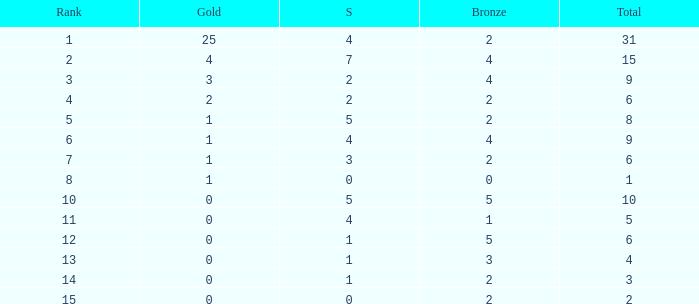Would you be able to parse every entry in this table? {'header': ['Rank', 'Gold', 'S', 'Bronze', 'Total'], 'rows': [['1', '25', '4', '2', '31'], ['2', '4', '7', '4', '15'], ['3', '3', '2', '4', '9'], ['4', '2', '2', '2', '6'], ['5', '1', '5', '2', '8'], ['6', '1', '4', '4', '9'], ['7', '1', '3', '2', '6'], ['8', '1', '0', '0', '1'], ['10', '0', '5', '5', '10'], ['11', '0', '4', '1', '5'], ['12', '0', '1', '5', '6'], ['13', '0', '1', '3', '4'], ['14', '0', '1', '2', '3'], ['15', '0', '0', '2', '2']]} What is the highest rank of the medal total less than 15, more than 2 bronzes, 0 gold and 1 silver? 13.0. 